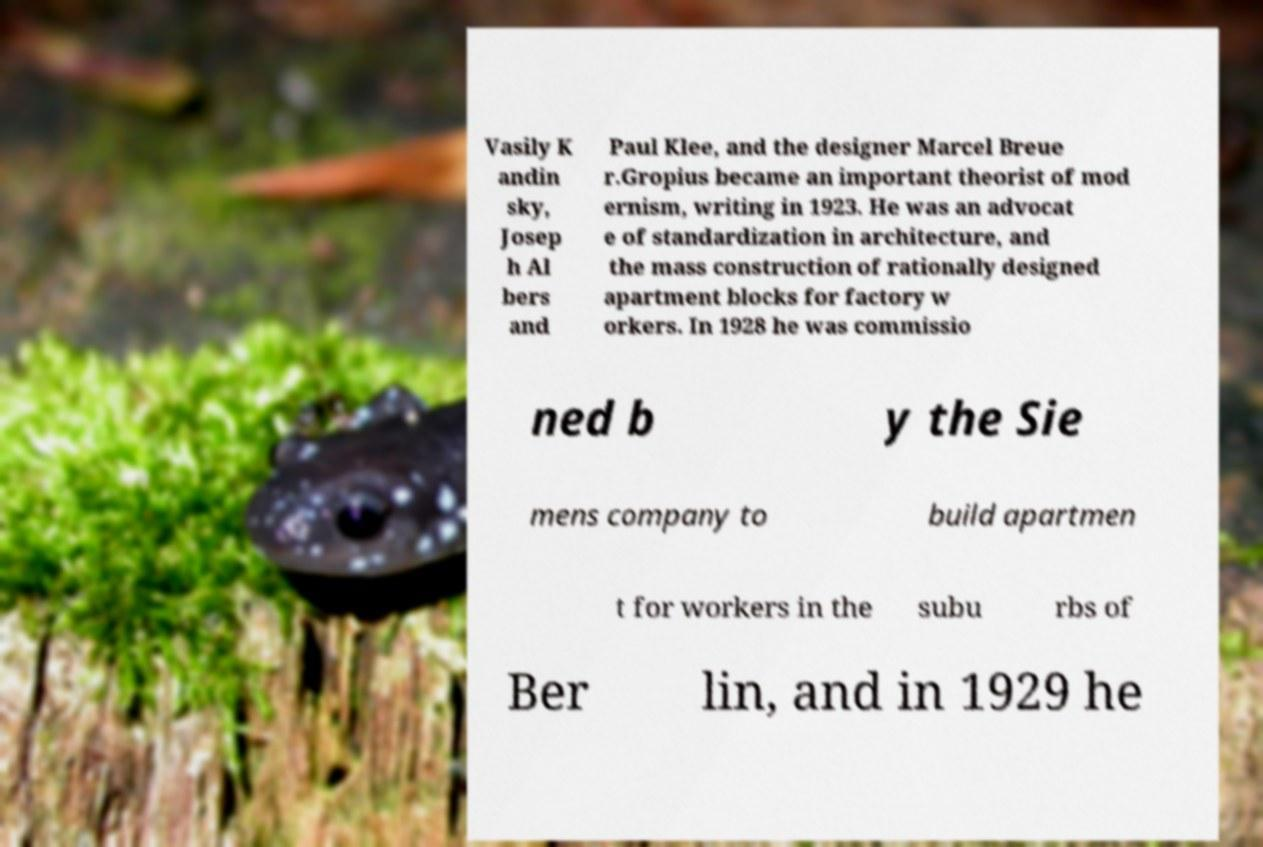For documentation purposes, I need the text within this image transcribed. Could you provide that? Vasily K andin sky, Josep h Al bers and Paul Klee, and the designer Marcel Breue r.Gropius became an important theorist of mod ernism, writing in 1923. He was an advocat e of standardization in architecture, and the mass construction of rationally designed apartment blocks for factory w orkers. In 1928 he was commissio ned b y the Sie mens company to build apartmen t for workers in the subu rbs of Ber lin, and in 1929 he 